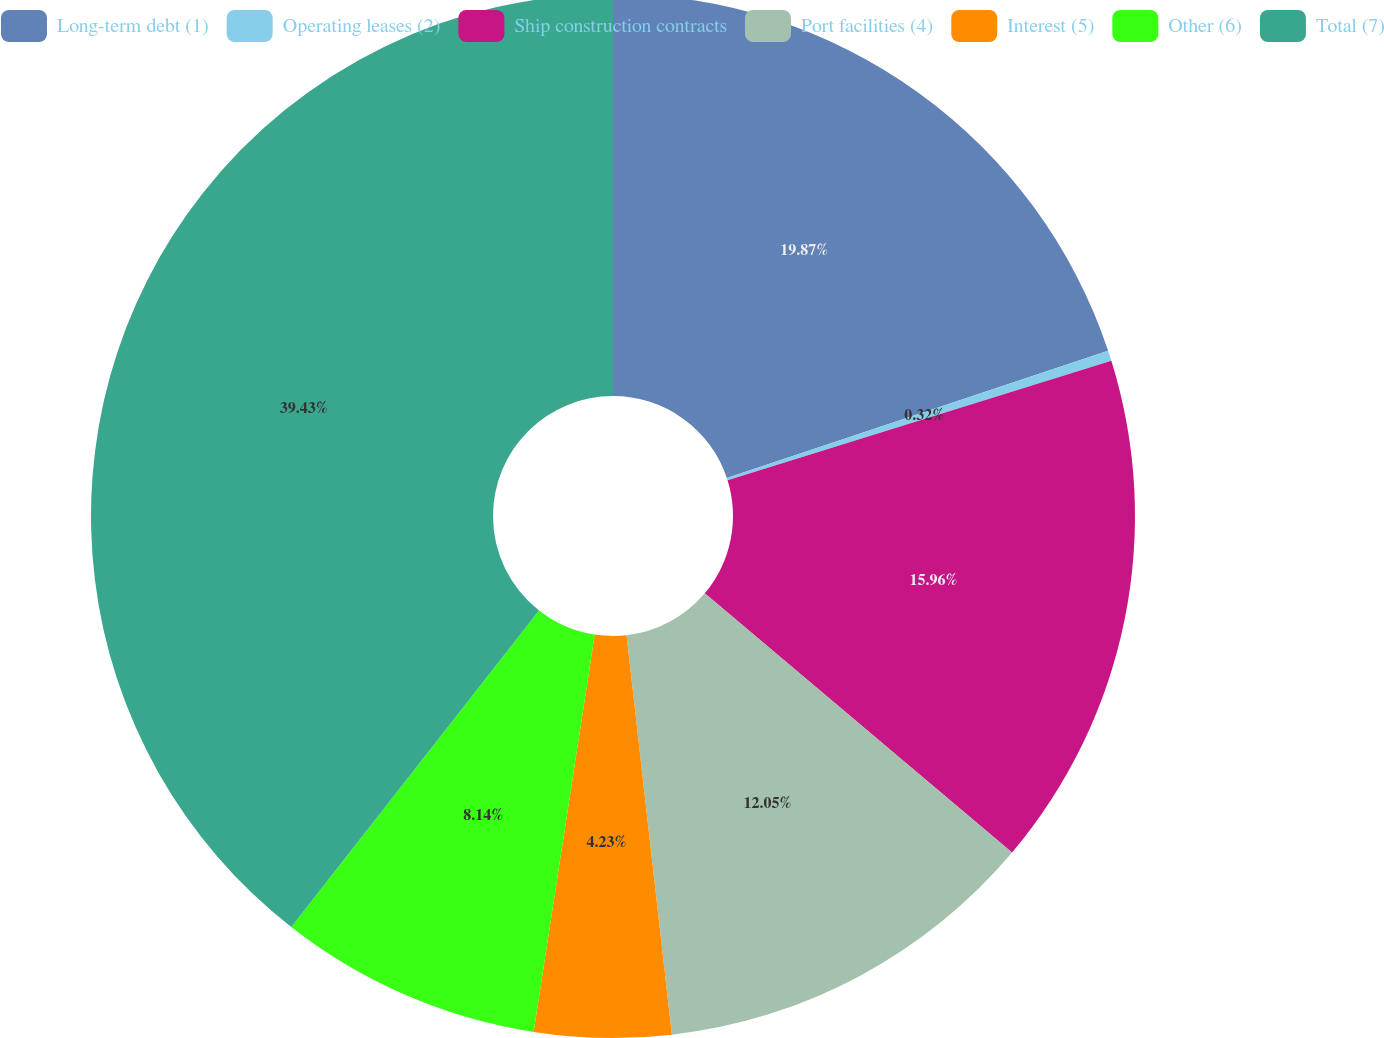<chart> <loc_0><loc_0><loc_500><loc_500><pie_chart><fcel>Long-term debt (1)<fcel>Operating leases (2)<fcel>Ship construction contracts<fcel>Port facilities (4)<fcel>Interest (5)<fcel>Other (6)<fcel>Total (7)<nl><fcel>19.87%<fcel>0.32%<fcel>15.96%<fcel>12.05%<fcel>4.23%<fcel>8.14%<fcel>39.43%<nl></chart> 